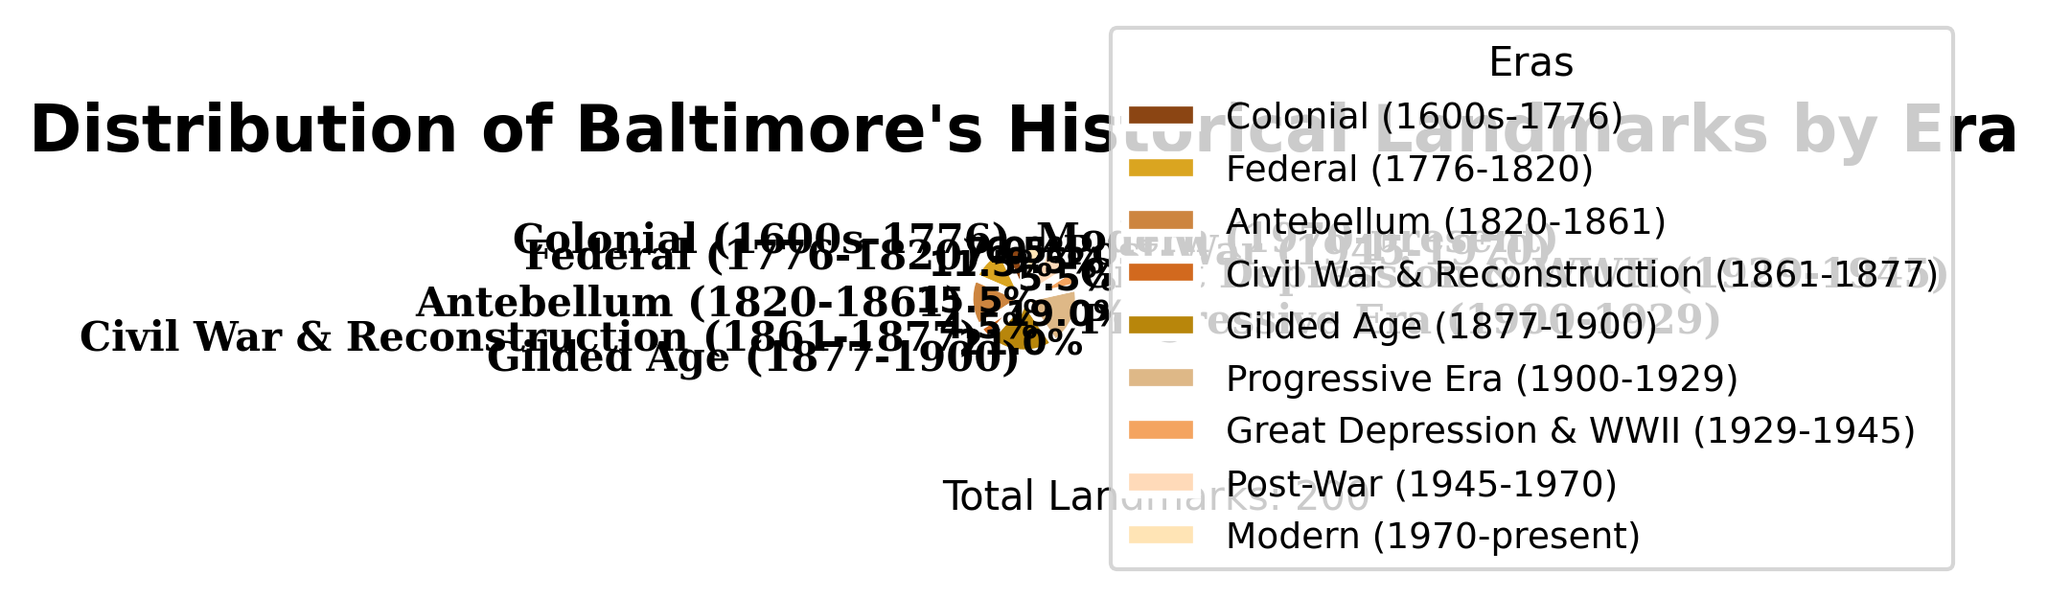What era has the highest number of historical landmarks in Baltimore? The era with the highest number of historical landmarks has the largest sector in the pie chart. From the chart, the Gilded Age (1877-1900) occupies the largest segment, indicating it has the highest number of landmarks.
Answer: Gilded Age (1877-1900) What is the combined percentage of historical landmarks from the Colonial and Modern eras? The respective percentages for the Colonial (1600s-1776) and Modern (1970-present) eras can be found on the pie chart. Adding the two percentages provides the combined percentage. The Colonial era has 9.0% and the Modern era has 8.4%, adding up to 17.4%.
Answer: 17.4% How does the number of landmarks during the Antebellum era compare to those in the Federal era? Comparing the sizes of the segments in the pie chart corresponding to the Antebellum (1820-1861) and Federal (1776-1820) eras, the Antebellum segment is larger. This indicates more landmarks in the Antebellum era.
Answer: Antebellum has more landmarks Which eras have fewer than 10% of the total historical landmarks? By examining the sectors of the pie chart, the percentages annotated show that the Civil War & Reconstruction, Great Depression & WWII, Colonial, and Modern eras each have less than 10% of the total landmarks.
Answer: Civil War & Reconstruction, Great Depression & WWII, Colonial, Modern What's the ratio of landmarks in the Gilded Age to those in the Civil War & Reconstruction era? The number of landmarks in the Gilded Age (1877-1900) is 42, and in the Civil War & Reconstruction (1861-1877), it's 9. Dividing these two numbers gives the ratio: 42/9 = 4.67.
Answer: 4.67 Is the number of historical landmarks in the Progressive Era greater than the Post-War era? Observing the pie chart, the Progressive Era (1900-1929) slice is larger than the Post-War (1945-1970) slice. This indicates the Progressive Era has more landmarks.
Answer: Yes What percentage of the total landmarks fall within the Great Depression & WWII and Post-War eras combined? Summing the percentages for the Great Depression & WWII (5.6%) and Post-War (9.7%) eras from the pie chart gives the combined percentage: 5.6% + 9.7% = 15.3%.
Answer: 15.3% Which era has the smallest number of historical landmarks, and what is the percentage of this era out of the total? The pie chart indicates that the smallest segment belongs to the Civil War & Reconstruction (1861-1877) era, with a percentage of 7.2%.
Answer: Civil War & Reconstruction, 7.2% What is the numerical difference between the landmarks in the Federal and Modern eras? The Federal (1776-1820) era has 23 landmarks, and the Modern (1970-present) era has 13 landmarks. Subtracting these gives the numerical difference: 23 - 13 = 10.
Answer: 10 